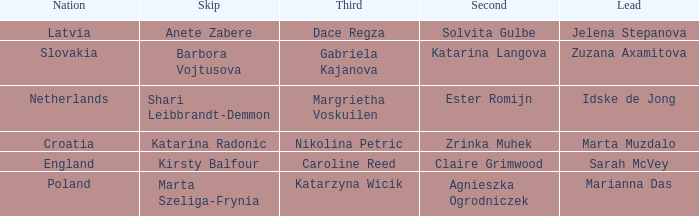Who is the Second with Nikolina Petric as Third? Zrinka Muhek. Can you give me this table as a dict? {'header': ['Nation', 'Skip', 'Third', 'Second', 'Lead'], 'rows': [['Latvia', 'Anete Zabere', 'Dace Regza', 'Solvita Gulbe', 'Jelena Stepanova'], ['Slovakia', 'Barbora Vojtusova', 'Gabriela Kajanova', 'Katarina Langova', 'Zuzana Axamitova'], ['Netherlands', 'Shari Leibbrandt-Demmon', 'Margrietha Voskuilen', 'Ester Romijn', 'Idske de Jong'], ['Croatia', 'Katarina Radonic', 'Nikolina Petric', 'Zrinka Muhek', 'Marta Muzdalo'], ['England', 'Kirsty Balfour', 'Caroline Reed', 'Claire Grimwood', 'Sarah McVey'], ['Poland', 'Marta Szeliga-Frynia', 'Katarzyna Wicik', 'Agnieszka Ogrodniczek', 'Marianna Das']]} 